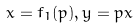<formula> <loc_0><loc_0><loc_500><loc_500>x = f _ { 1 } ( p ) , y = p x</formula> 